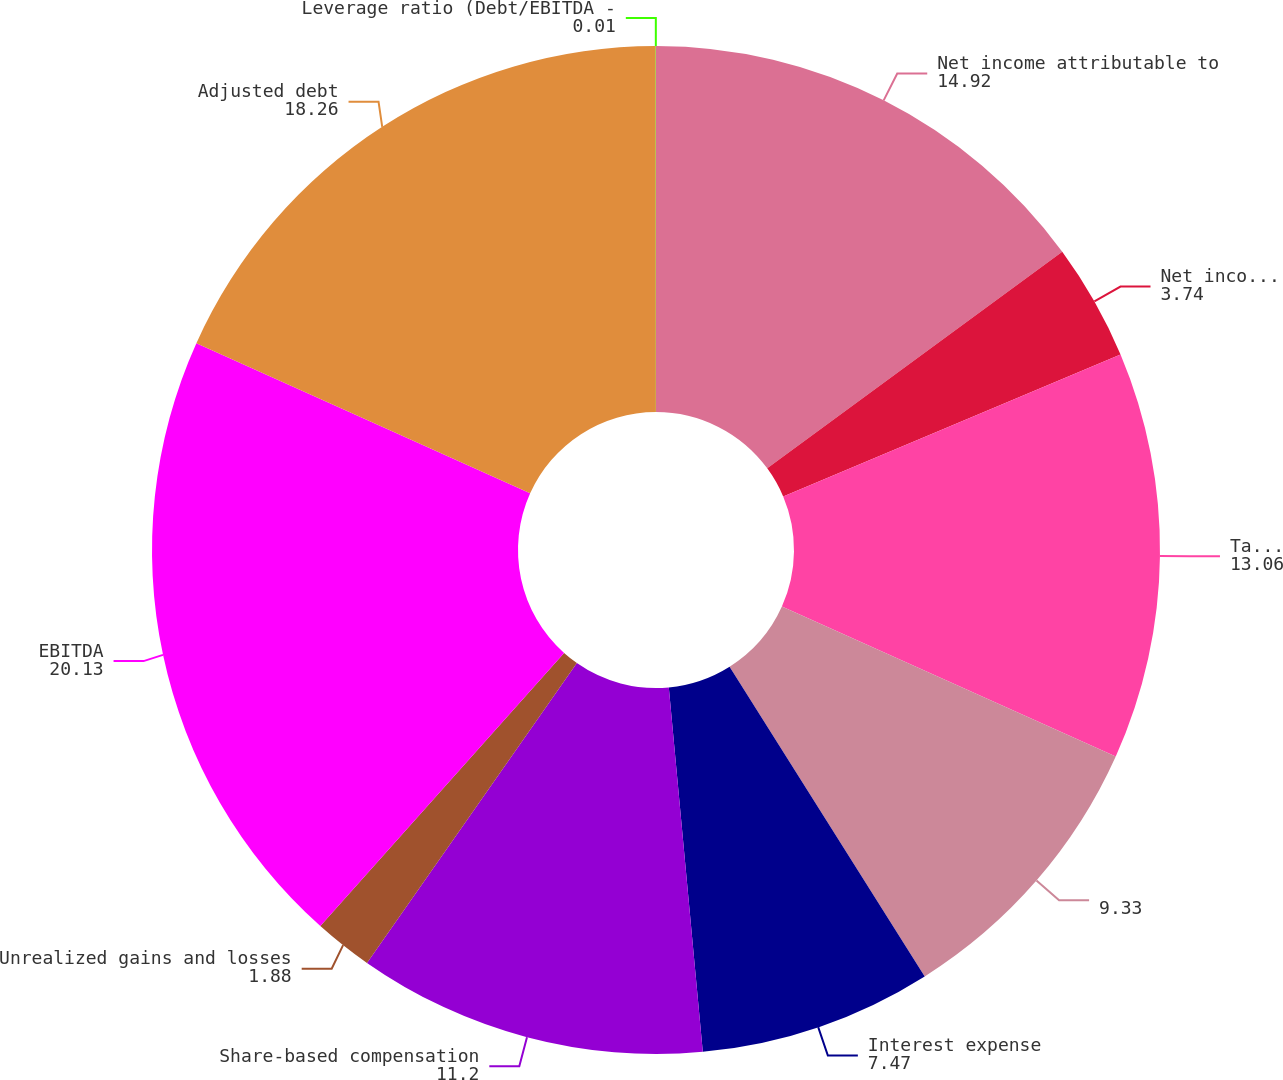<chart> <loc_0><loc_0><loc_500><loc_500><pie_chart><fcel>Net income attributable to<fcel>Net income/(loss) attributable<fcel>Tax expense<fcel>Unnamed: 3<fcel>Interest expense<fcel>Share-based compensation<fcel>Unrealized gains and losses<fcel>EBITDA<fcel>Adjusted debt<fcel>Leverage ratio (Debt/EBITDA -<nl><fcel>14.92%<fcel>3.74%<fcel>13.06%<fcel>9.33%<fcel>7.47%<fcel>11.2%<fcel>1.88%<fcel>20.13%<fcel>18.26%<fcel>0.01%<nl></chart> 